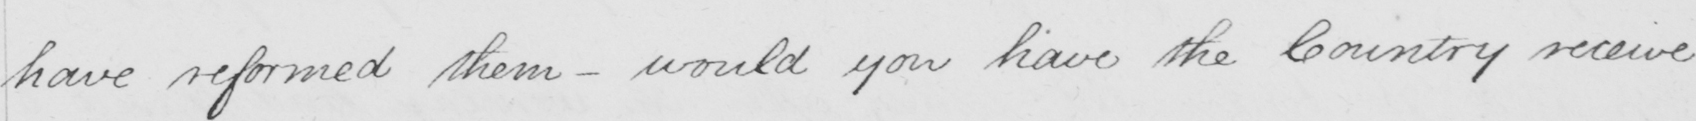Please provide the text content of this handwritten line. have reformed them  _  would you have the Country receive 